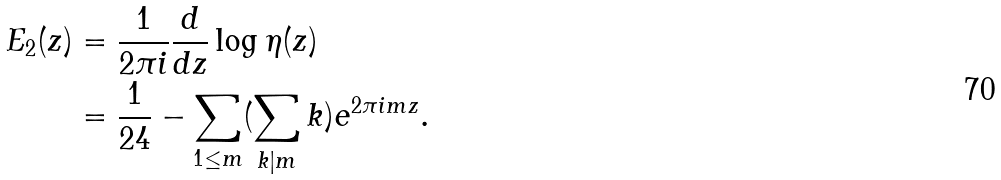Convert formula to latex. <formula><loc_0><loc_0><loc_500><loc_500>E _ { 2 } ( z ) & = \frac { 1 } { 2 \pi i } \frac { d } { d z } \log \eta ( z ) \\ & = \frac { 1 } { 2 4 } - \sum _ { 1 \leq m } ( \sum _ { k | m } k ) e ^ { 2 \pi i m z } .</formula> 